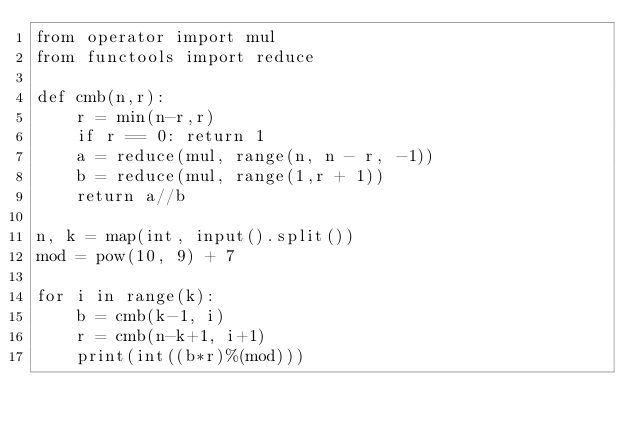Convert code to text. <code><loc_0><loc_0><loc_500><loc_500><_Python_>from operator import mul
from functools import reduce

def cmb(n,r):
    r = min(n-r,r)
    if r == 0: return 1
    a = reduce(mul, range(n, n - r, -1))
    b = reduce(mul, range(1,r + 1))
    return a//b

n, k = map(int, input().split())
mod = pow(10, 9) + 7

for i in range(k):
    b = cmb(k-1, i)
    r = cmb(n-k+1, i+1)
    print(int((b*r)%(mod)))
</code> 